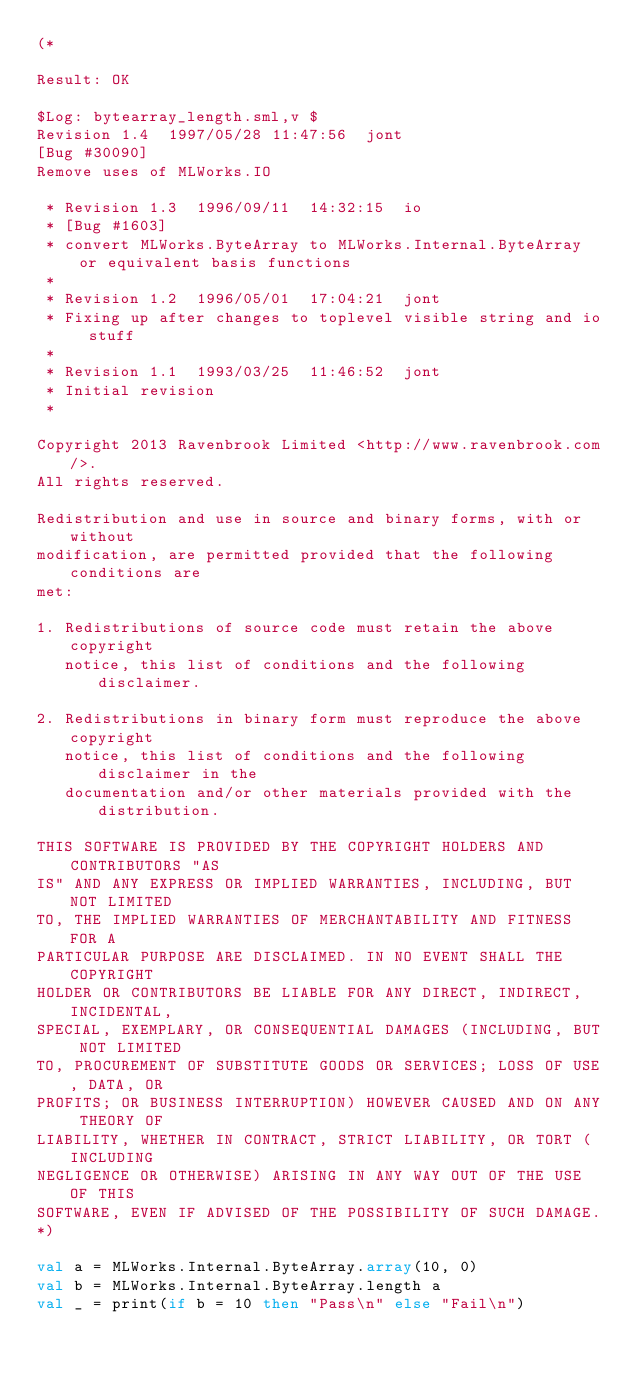<code> <loc_0><loc_0><loc_500><loc_500><_SML_>(*

Result: OK
 
$Log: bytearray_length.sml,v $
Revision 1.4  1997/05/28 11:47:56  jont
[Bug #30090]
Remove uses of MLWorks.IO

 * Revision 1.3  1996/09/11  14:32:15  io
 * [Bug #1603]
 * convert MLWorks.ByteArray to MLWorks.Internal.ByteArray or equivalent basis functions
 *
 * Revision 1.2  1996/05/01  17:04:21  jont
 * Fixing up after changes to toplevel visible string and io stuff
 *
 * Revision 1.1  1993/03/25  11:46:52  jont
 * Initial revision
 *

Copyright 2013 Ravenbrook Limited <http://www.ravenbrook.com/>.
All rights reserved.

Redistribution and use in source and binary forms, with or without
modification, are permitted provided that the following conditions are
met:

1. Redistributions of source code must retain the above copyright
   notice, this list of conditions and the following disclaimer.

2. Redistributions in binary form must reproduce the above copyright
   notice, this list of conditions and the following disclaimer in the
   documentation and/or other materials provided with the distribution.

THIS SOFTWARE IS PROVIDED BY THE COPYRIGHT HOLDERS AND CONTRIBUTORS "AS
IS" AND ANY EXPRESS OR IMPLIED WARRANTIES, INCLUDING, BUT NOT LIMITED
TO, THE IMPLIED WARRANTIES OF MERCHANTABILITY AND FITNESS FOR A
PARTICULAR PURPOSE ARE DISCLAIMED. IN NO EVENT SHALL THE COPYRIGHT
HOLDER OR CONTRIBUTORS BE LIABLE FOR ANY DIRECT, INDIRECT, INCIDENTAL,
SPECIAL, EXEMPLARY, OR CONSEQUENTIAL DAMAGES (INCLUDING, BUT NOT LIMITED
TO, PROCUREMENT OF SUBSTITUTE GOODS OR SERVICES; LOSS OF USE, DATA, OR
PROFITS; OR BUSINESS INTERRUPTION) HOWEVER CAUSED AND ON ANY THEORY OF
LIABILITY, WHETHER IN CONTRACT, STRICT LIABILITY, OR TORT (INCLUDING
NEGLIGENCE OR OTHERWISE) ARISING IN ANY WAY OUT OF THE USE OF THIS
SOFTWARE, EVEN IF ADVISED OF THE POSSIBILITY OF SUCH DAMAGE.
*)

val a = MLWorks.Internal.ByteArray.array(10, 0)
val b = MLWorks.Internal.ByteArray.length a
val _ = print(if b = 10 then "Pass\n" else "Fail\n")
</code> 